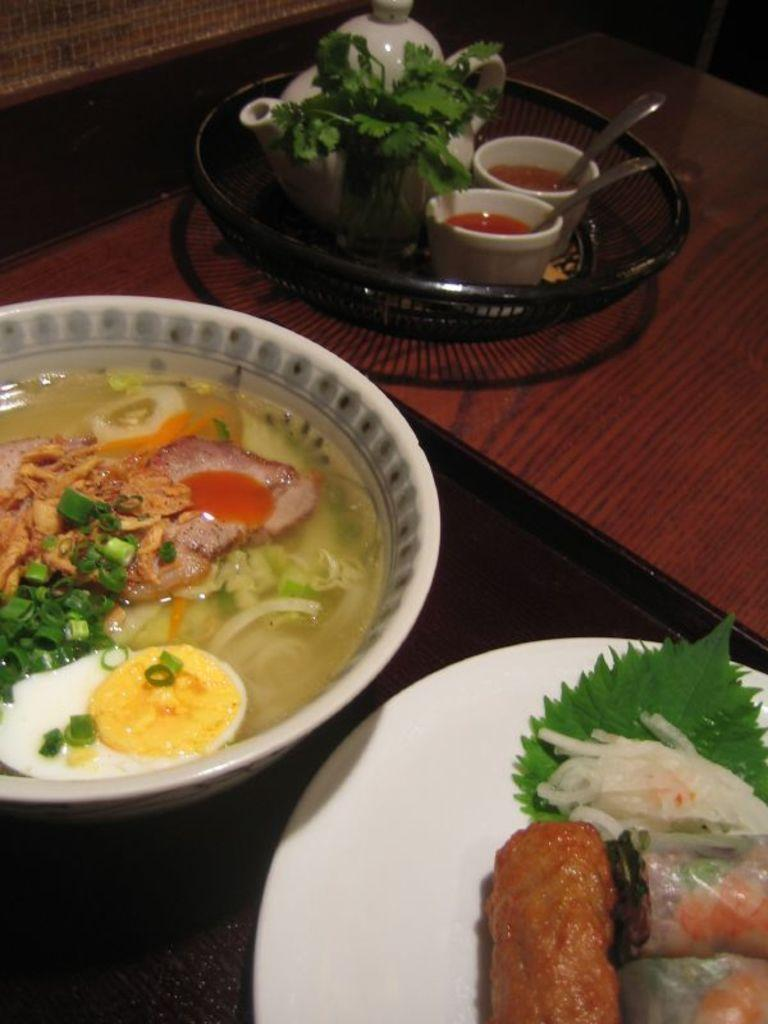What piece of furniture is present in the image? There is a table in the image. What items are on the table? There are bowls, sauces, spoons, a teapot, a plate, and a tray on the table. What might be used for serving or holding food in the image? The plate and tray on the table can be used for serving or holding food. What is the purpose of the teapot in the image? The teapot is likely used for serving tea or another hot beverage. What type of bread is being served on the table in the image? There is no bread present in the image; only bowls, sauces, spoons, a teapot, a plate, and a tray are visible. What time of day is it in the image, based on the presence of a pickle? There is no pickle present in the image, and therefore no indication of the time of day. 